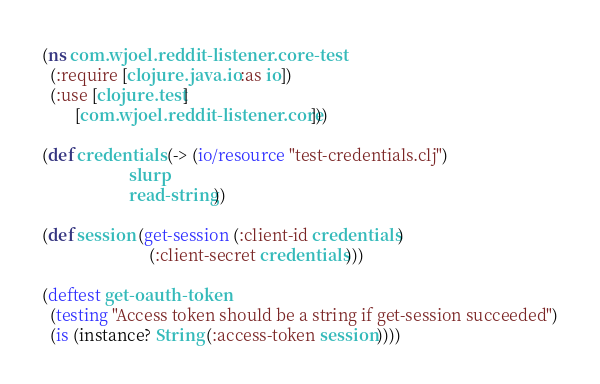Convert code to text. <code><loc_0><loc_0><loc_500><loc_500><_Clojure_>(ns com.wjoel.reddit-listener.core-test
  (:require [clojure.java.io :as io])
  (:use [clojure.test]
        [com.wjoel.reddit-listener.core]))

(def credentials (-> (io/resource "test-credentials.clj")
                     slurp
                     read-string))

(def session (get-session (:client-id credentials)
                          (:client-secret credentials)))

(deftest get-oauth-token
  (testing "Access token should be a string if get-session succeeded")
  (is (instance? String (:access-token session))))
</code> 